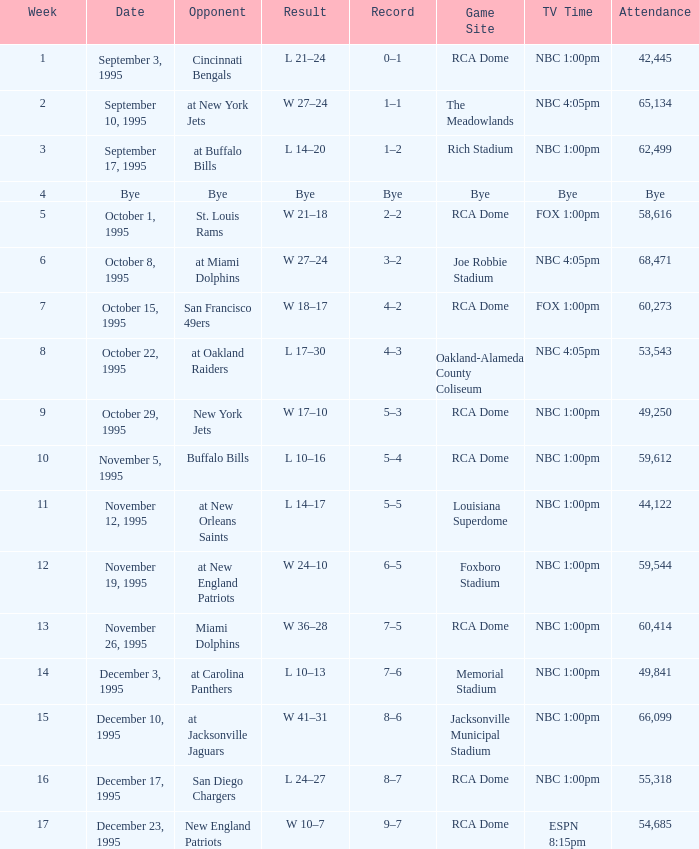Could you parse the entire table as a dict? {'header': ['Week', 'Date', 'Opponent', 'Result', 'Record', 'Game Site', 'TV Time', 'Attendance'], 'rows': [['1', 'September 3, 1995', 'Cincinnati Bengals', 'L 21–24', '0–1', 'RCA Dome', 'NBC 1:00pm', '42,445'], ['2', 'September 10, 1995', 'at New York Jets', 'W 27–24', '1–1', 'The Meadowlands', 'NBC 4:05pm', '65,134'], ['3', 'September 17, 1995', 'at Buffalo Bills', 'L 14–20', '1–2', 'Rich Stadium', 'NBC 1:00pm', '62,499'], ['4', 'Bye', 'Bye', 'Bye', 'Bye', 'Bye', 'Bye', 'Bye'], ['5', 'October 1, 1995', 'St. Louis Rams', 'W 21–18', '2–2', 'RCA Dome', 'FOX 1:00pm', '58,616'], ['6', 'October 8, 1995', 'at Miami Dolphins', 'W 27–24', '3–2', 'Joe Robbie Stadium', 'NBC 4:05pm', '68,471'], ['7', 'October 15, 1995', 'San Francisco 49ers', 'W 18–17', '4–2', 'RCA Dome', 'FOX 1:00pm', '60,273'], ['8', 'October 22, 1995', 'at Oakland Raiders', 'L 17–30', '4–3', 'Oakland-Alameda County Coliseum', 'NBC 4:05pm', '53,543'], ['9', 'October 29, 1995', 'New York Jets', 'W 17–10', '5–3', 'RCA Dome', 'NBC 1:00pm', '49,250'], ['10', 'November 5, 1995', 'Buffalo Bills', 'L 10–16', '5–4', 'RCA Dome', 'NBC 1:00pm', '59,612'], ['11', 'November 12, 1995', 'at New Orleans Saints', 'L 14–17', '5–5', 'Louisiana Superdome', 'NBC 1:00pm', '44,122'], ['12', 'November 19, 1995', 'at New England Patriots', 'W 24–10', '6–5', 'Foxboro Stadium', 'NBC 1:00pm', '59,544'], ['13', 'November 26, 1995', 'Miami Dolphins', 'W 36–28', '7–5', 'RCA Dome', 'NBC 1:00pm', '60,414'], ['14', 'December 3, 1995', 'at Carolina Panthers', 'L 10–13', '7–6', 'Memorial Stadium', 'NBC 1:00pm', '49,841'], ['15', 'December 10, 1995', 'at Jacksonville Jaguars', 'W 41–31', '8–6', 'Jacksonville Municipal Stadium', 'NBC 1:00pm', '66,099'], ['16', 'December 17, 1995', 'San Diego Chargers', 'L 24–27', '8–7', 'RCA Dome', 'NBC 1:00pm', '55,318'], ['17', 'December 23, 1995', 'New England Patriots', 'W 10–7', '9–7', 'RCA Dome', 'ESPN 8:15pm', '54,685']]} What's the Opponent with a Week that's larger than 16? New England Patriots. 